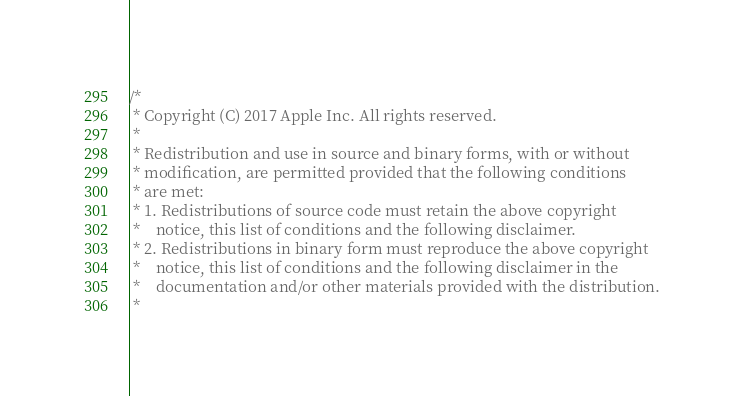Convert code to text. <code><loc_0><loc_0><loc_500><loc_500><_C_>/*
 * Copyright (C) 2017 Apple Inc. All rights reserved.
 *
 * Redistribution and use in source and binary forms, with or without
 * modification, are permitted provided that the following conditions
 * are met:
 * 1. Redistributions of source code must retain the above copyright
 *    notice, this list of conditions and the following disclaimer.
 * 2. Redistributions in binary form must reproduce the above copyright
 *    notice, this list of conditions and the following disclaimer in the
 *    documentation and/or other materials provided with the distribution.
 *</code> 